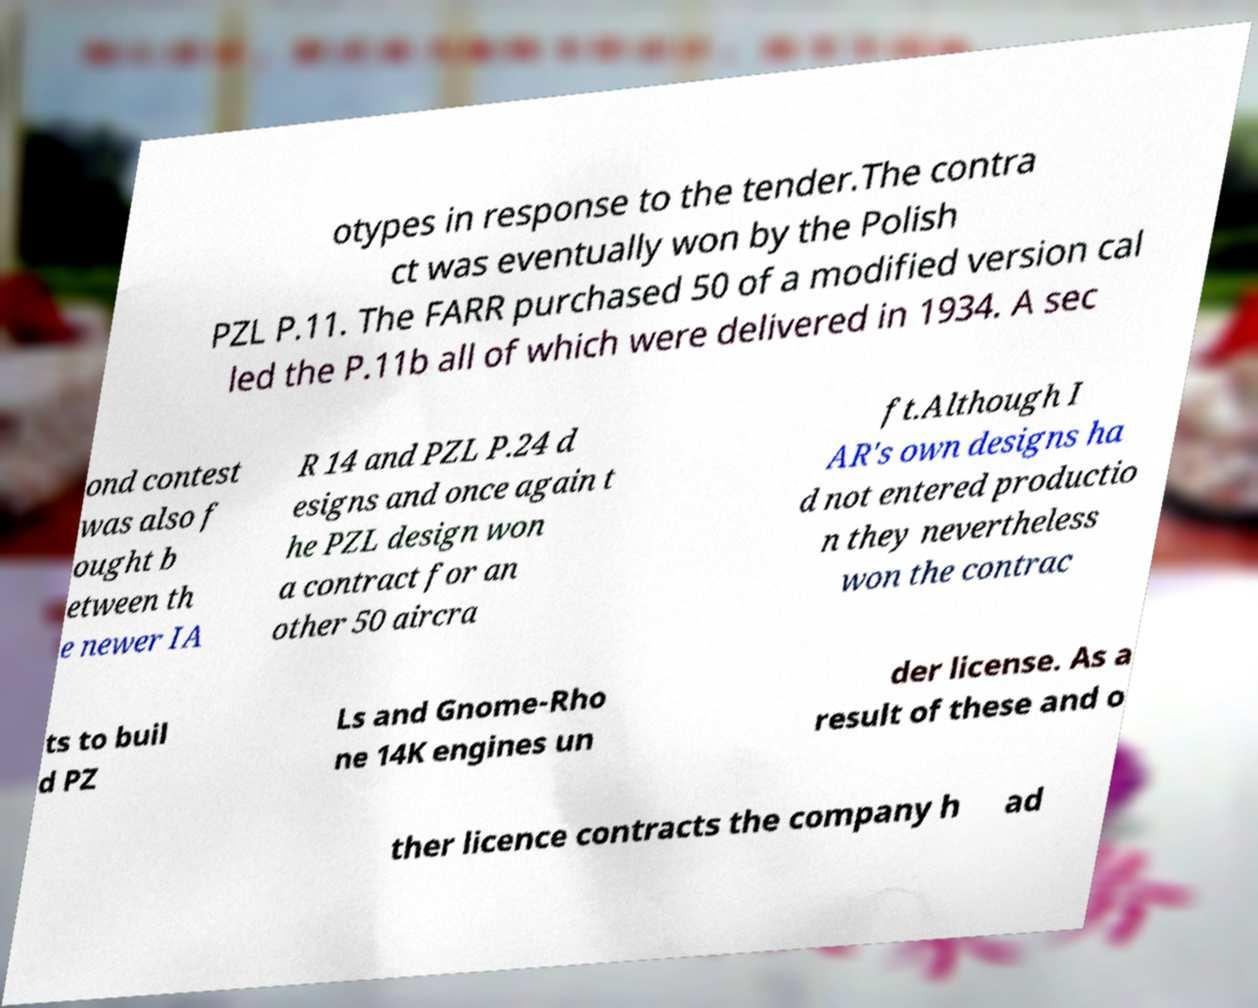I need the written content from this picture converted into text. Can you do that? otypes in response to the tender.The contra ct was eventually won by the Polish PZL P.11. The FARR purchased 50 of a modified version cal led the P.11b all of which were delivered in 1934. A sec ond contest was also f ought b etween th e newer IA R 14 and PZL P.24 d esigns and once again t he PZL design won a contract for an other 50 aircra ft.Although I AR's own designs ha d not entered productio n they nevertheless won the contrac ts to buil d PZ Ls and Gnome-Rho ne 14K engines un der license. As a result of these and o ther licence contracts the company h ad 